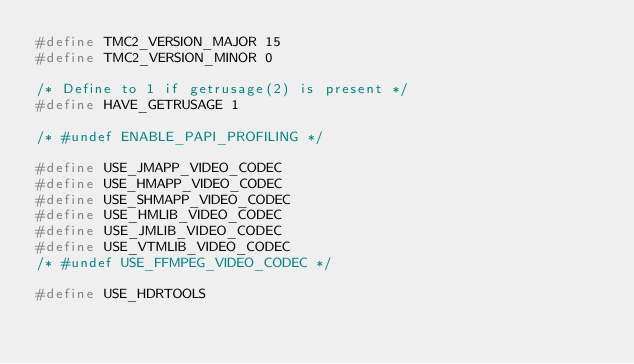Convert code to text. <code><loc_0><loc_0><loc_500><loc_500><_C_>#define TMC2_VERSION_MAJOR 15
#define TMC2_VERSION_MINOR 0

/* Define to 1 if getrusage(2) is present */
#define HAVE_GETRUSAGE 1

/* #undef ENABLE_PAPI_PROFILING */

#define USE_JMAPP_VIDEO_CODEC
#define USE_HMAPP_VIDEO_CODEC
#define USE_SHMAPP_VIDEO_CODEC
#define USE_HMLIB_VIDEO_CODEC
#define USE_JMLIB_VIDEO_CODEC
#define USE_VTMLIB_VIDEO_CODEC
/* #undef USE_FFMPEG_VIDEO_CODEC */

#define USE_HDRTOOLS



</code> 